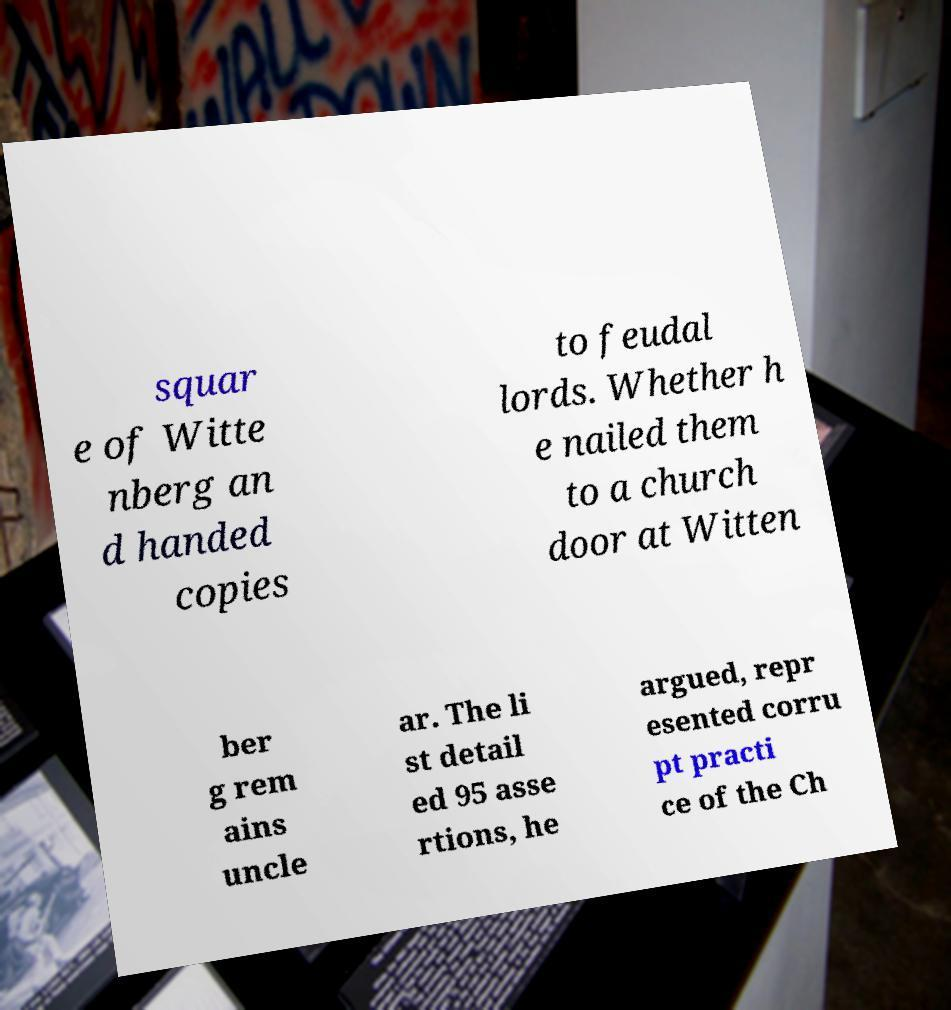I need the written content from this picture converted into text. Can you do that? squar e of Witte nberg an d handed copies to feudal lords. Whether h e nailed them to a church door at Witten ber g rem ains uncle ar. The li st detail ed 95 asse rtions, he argued, repr esented corru pt practi ce of the Ch 